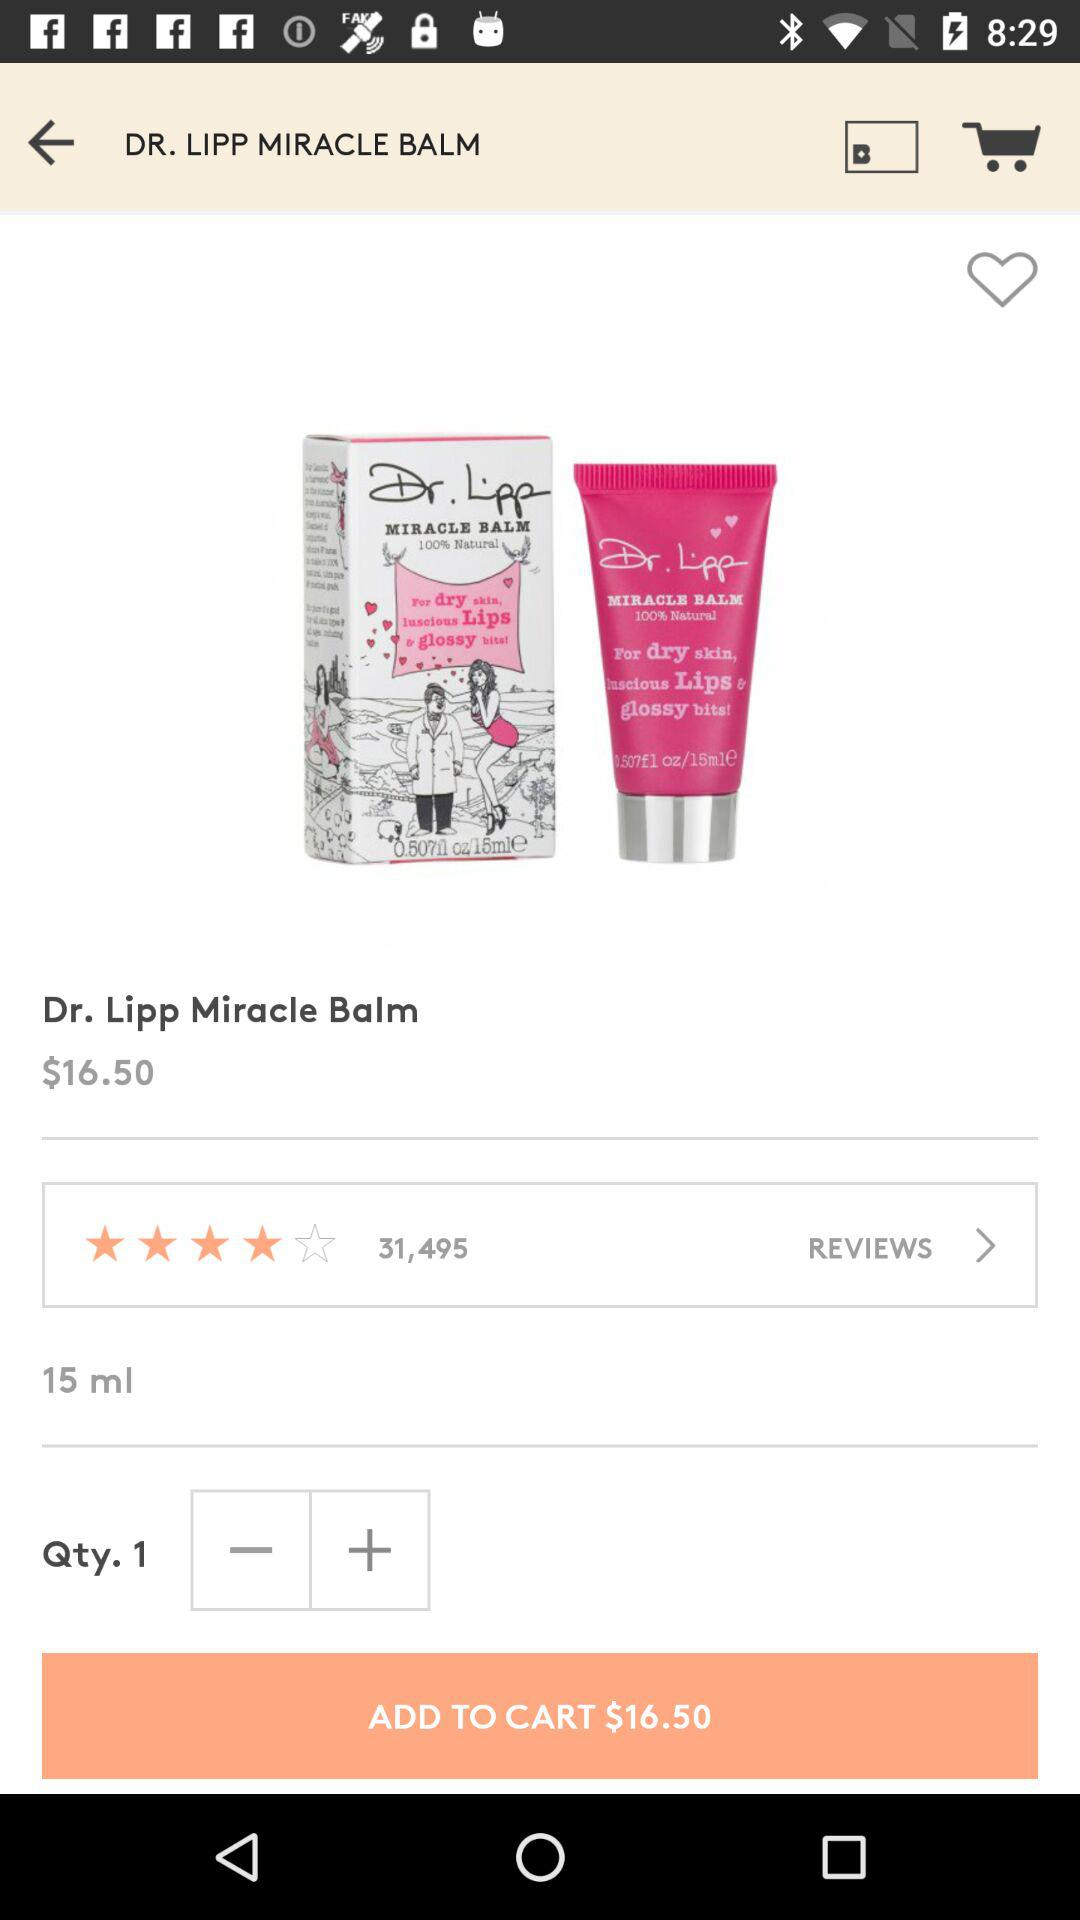What is the price of the product?
Answer the question using a single word or phrase. $16.50 